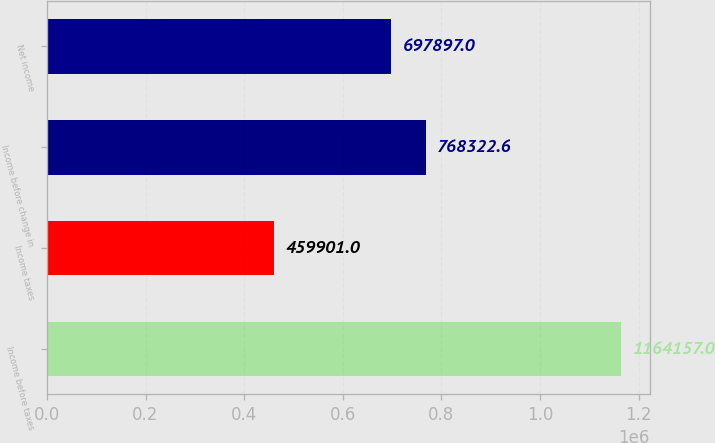Convert chart to OTSL. <chart><loc_0><loc_0><loc_500><loc_500><bar_chart><fcel>Income before taxes<fcel>Income taxes<fcel>Income before change in<fcel>Net income<nl><fcel>1.16416e+06<fcel>459901<fcel>768323<fcel>697897<nl></chart> 